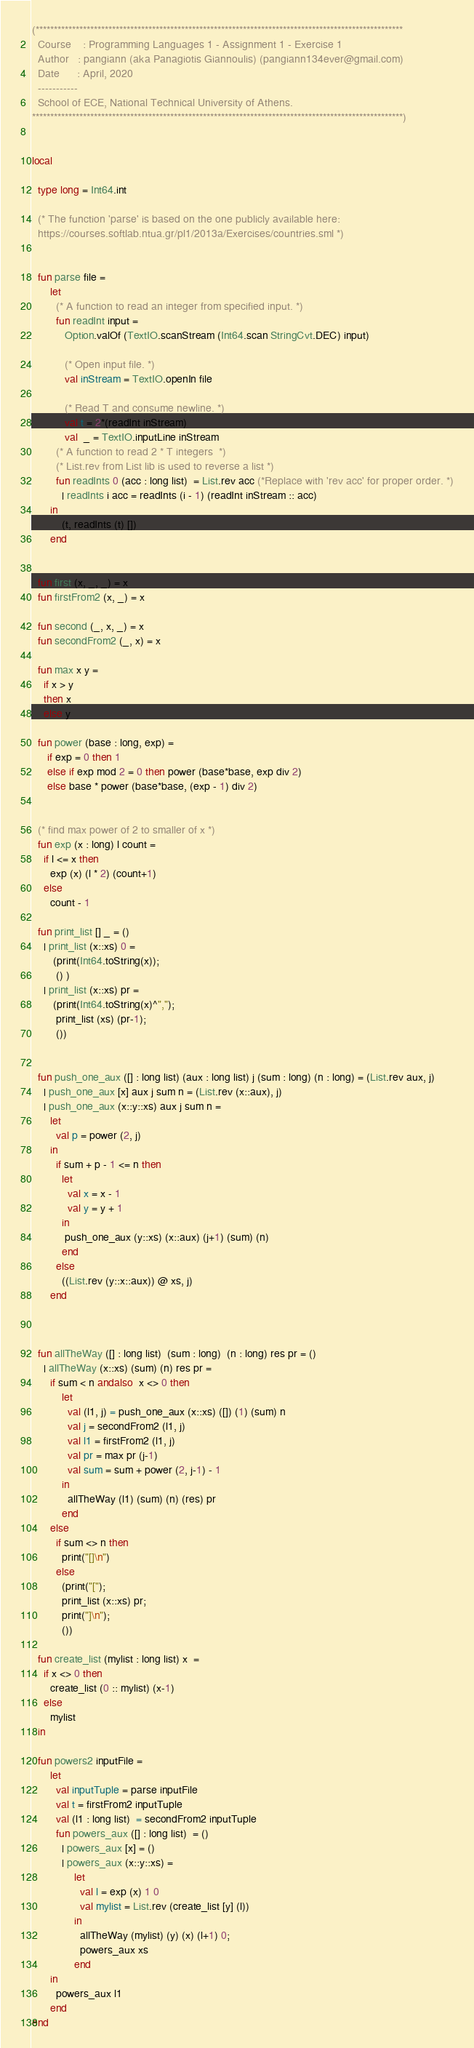Convert code to text. <code><loc_0><loc_0><loc_500><loc_500><_SML_>
(*****************************************************************************************************
  Course    : Programming Languages 1 - Assignment 1 - Exercise 1
  Author   : pangiann (aka Panagiotis Giannoulis) (pangiann134ever@gmail.com)
  Date      : April, 2020
  -----------
  School of ECE, National Technical University of Athens.
******************************************************************************************************)


local

  type long = Int64.int

  (* The function 'parse' is based on the one publicly available here:
  https://courses.softlab.ntua.gr/pl1/2013a/Exercises/countries.sml *)


  fun parse file =
      let
        (* A function to read an integer from specified input. *)
        fun readInt input =
           Option.valOf (TextIO.scanStream (Int64.scan StringCvt.DEC) input)

           (* Open input file. *)
           val inStream = TextIO.openIn file

           (* Read T and consume newline. *)
           val t = 2*(readInt inStream)
           val  _ = TextIO.inputLine inStream
        (* A function to read 2 * T integers  *)
        (* List.rev from List lib is used to reverse a list *)
        fun readInts 0 (acc : long list)  = List.rev acc (*Replace with 'rev acc' for proper order. *)
          | readInts i acc = readInts (i - 1) (readInt inStream :: acc)
      in
          (t, readInts (t) [])
      end


  fun first (x, _, _) = x
  fun firstFrom2 (x, _) = x

  fun second (_, x, _) = x
  fun secondFrom2 (_, x) = x

  fun max x y =
    if x > y
    then x
    else y

  fun power (base : long, exp) =
     if exp = 0 then 1
     else if exp mod 2 = 0 then power (base*base, exp div 2)
     else base * power (base*base, (exp - 1) div 2)


  (* find max power of 2 to smaller of x *)
  fun exp (x : long) l count =
    if l <= x then
      exp (x) (l * 2) (count+1)
    else
      count - 1

  fun print_list [] _ = ()
    | print_list (x::xs) 0 =
       (print(Int64.toString(x));
        () )
    | print_list (x::xs) pr = 
       (print(Int64.toString(x)^",");
        print_list (xs) (pr-1);
        ())
       

  fun push_one_aux ([] : long list) (aux : long list) j (sum : long) (n : long) = (List.rev aux, j)
    | push_one_aux [x] aux j sum n = (List.rev (x::aux), j)   
    | push_one_aux (x::y::xs) aux j sum n = 
      let
        val p = power (2, j)
      in
        if sum + p - 1 <= n then
          let
            val x = x - 1
            val y = y + 1
          in
           push_one_aux (y::xs) (x::aux) (j+1) (sum) (n)
          end
        else
          ((List.rev (y::x::aux)) @ xs, j)
      end



  fun allTheWay ([] : long list)  (sum : long)  (n : long) res pr = ()
    | allTheWay (x::xs) (sum) (n) res pr =
      if sum < n andalso  x <> 0 then
          let
            val (l1, j) = push_one_aux (x::xs) ([]) (1) (sum) n
            val j = secondFrom2 (l1, j)
            val l1 = firstFrom2 (l1, j)
            val pr = max pr (j-1)
            val sum = sum + power (2, j-1) - 1
          in
            allTheWay (l1) (sum) (n) (res) pr
          end
      else
        if sum <> n then
          print("[]\n")
        else
          (print("[");
          print_list (x::xs) pr;
          print("]\n");
          ())

  fun create_list (mylist : long list) x  = 
    if x <> 0 then
      create_list (0 :: mylist) (x-1)
    else
      mylist
  in

  fun powers2 inputFile =
      let
        val inputTuple = parse inputFile
        val t = firstFrom2 inputTuple
        val (l1 : long list)  = secondFrom2 inputTuple
        fun powers_aux ([] : long list)  = ()
          | powers_aux [x] = () 
          | powers_aux (x::y::xs) =
              let
                val l = exp (x) 1 0
                val mylist = List.rev (create_list [y] (l))
              in
                allTheWay (mylist) (y) (x) (l+1) 0;
                powers_aux xs
              end
      in
        powers_aux l1
      end
end
</code> 